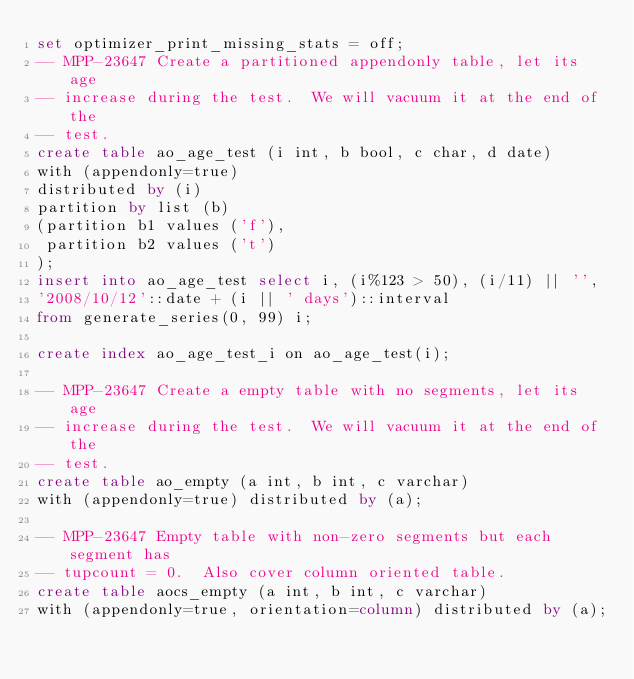Convert code to text. <code><loc_0><loc_0><loc_500><loc_500><_SQL_>set optimizer_print_missing_stats = off;
-- MPP-23647 Create a partitioned appendonly table, let its age
-- increase during the test.  We will vacuum it at the end of the
-- test.
create table ao_age_test (i int, b bool, c char, d date)
with (appendonly=true)
distributed by (i)
partition by list (b)
(partition b1 values ('f'),
 partition b2 values ('t')
);
insert into ao_age_test select i, (i%123 > 50), (i/11) || '',
'2008/10/12'::date + (i || ' days')::interval
from generate_series(0, 99) i;

create index ao_age_test_i on ao_age_test(i);

-- MPP-23647 Create a empty table with no segments, let its age
-- increase during the test.  We will vacuum it at the end of the
-- test.
create table ao_empty (a int, b int, c varchar)
with (appendonly=true) distributed by (a);

-- MPP-23647 Empty table with non-zero segments but each segment has
-- tupcount = 0.  Also cover column oriented table.
create table aocs_empty (a int, b int, c varchar)
with (appendonly=true, orientation=column) distributed by (a);</code> 